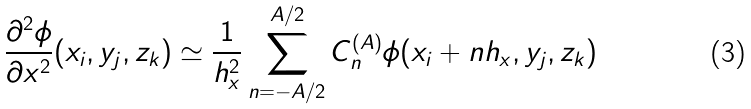Convert formula to latex. <formula><loc_0><loc_0><loc_500><loc_500>\frac { \partial ^ { 2 } \phi } { \partial x ^ { 2 } } ( x _ { i } , y _ { j } , z _ { k } ) \simeq \frac { 1 } { h _ { x } ^ { 2 } } \sum _ { n = - A / 2 } ^ { A / 2 } C _ { n } ^ { ( A ) } \phi ( x _ { i } + n h _ { x } , y _ { j } , z _ { k } )</formula> 